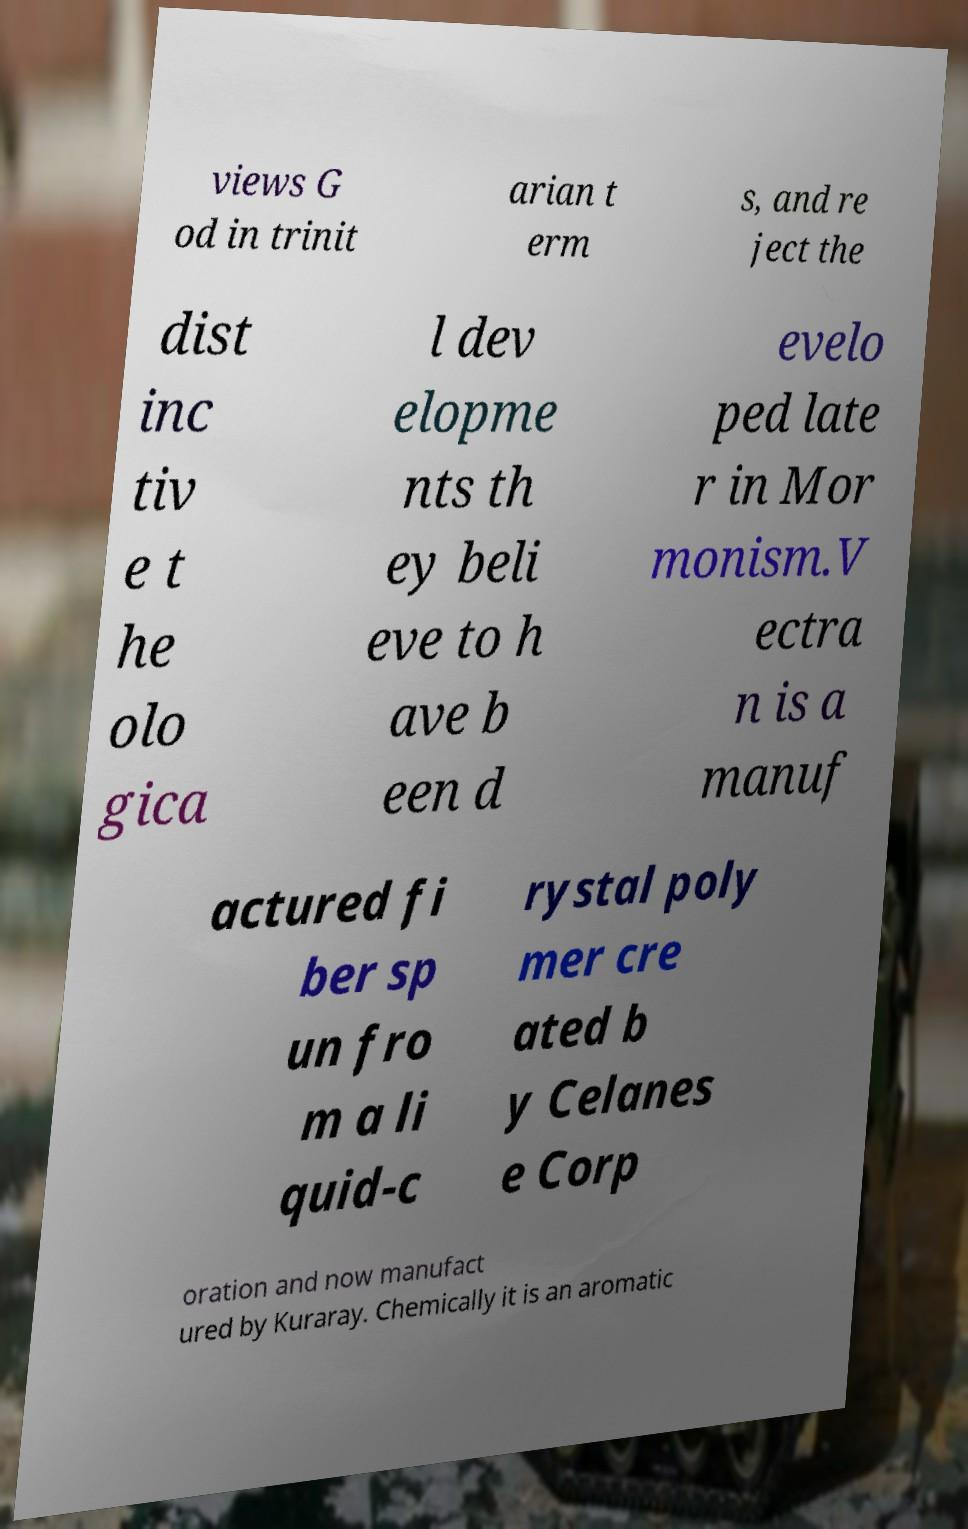I need the written content from this picture converted into text. Can you do that? views G od in trinit arian t erm s, and re ject the dist inc tiv e t he olo gica l dev elopme nts th ey beli eve to h ave b een d evelo ped late r in Mor monism.V ectra n is a manuf actured fi ber sp un fro m a li quid-c rystal poly mer cre ated b y Celanes e Corp oration and now manufact ured by Kuraray. Chemically it is an aromatic 